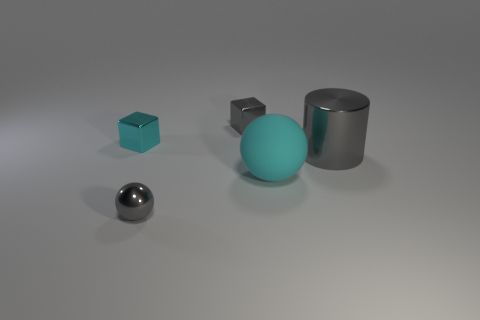There is a block behind the cyan metallic object; does it have the same color as the matte thing?
Make the answer very short. No. There is a tiny gray object in front of the big cyan rubber ball; what material is it?
Your answer should be very brief. Metal. What is the size of the gray block?
Provide a succinct answer. Small. Do the cyan thing in front of the big gray metallic cylinder and the cylinder have the same material?
Your response must be concise. No. What number of cyan metallic objects are there?
Offer a terse response. 1. What number of things are either cyan rubber spheres or cyan objects?
Offer a very short reply. 2. What number of cubes are on the left side of the metallic cube on the right side of the tiny gray shiny thing that is in front of the large matte object?
Offer a very short reply. 1. Is there anything else that has the same color as the large rubber ball?
Provide a succinct answer. Yes. There is a tiny metallic object that is behind the small cyan metal thing; is it the same color as the object to the right of the big cyan object?
Your response must be concise. Yes. Is the number of big gray cylinders that are to the right of the large cyan matte ball greater than the number of metal cylinders in front of the shiny sphere?
Give a very brief answer. Yes. 